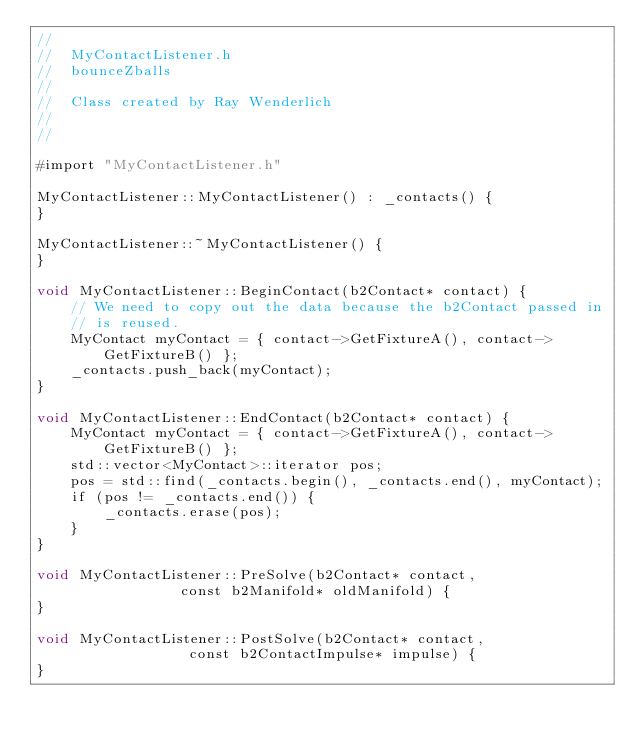Convert code to text. <code><loc_0><loc_0><loc_500><loc_500><_ObjectiveC_>//
//  MyContactListener.h
//  bounceZballs
//
//  Class created by Ray Wenderlich
//  
//

#import "MyContactListener.h"

MyContactListener::MyContactListener() : _contacts() {
}

MyContactListener::~MyContactListener() {
}

void MyContactListener::BeginContact(b2Contact* contact) {
    // We need to copy out the data because the b2Contact passed in
    // is reused.
    MyContact myContact = { contact->GetFixtureA(), contact->GetFixtureB() };
    _contacts.push_back(myContact);
}

void MyContactListener::EndContact(b2Contact* contact) {
    MyContact myContact = { contact->GetFixtureA(), contact->GetFixtureB() };
    std::vector<MyContact>::iterator pos;
    pos = std::find(_contacts.begin(), _contacts.end(), myContact);
    if (pos != _contacts.end()) {
        _contacts.erase(pos);
    }
}

void MyContactListener::PreSolve(b2Contact* contact, 
								 const b2Manifold* oldManifold) {
}

void MyContactListener::PostSolve(b2Contact* contact, 
								  const b2ContactImpulse* impulse) {
}
</code> 